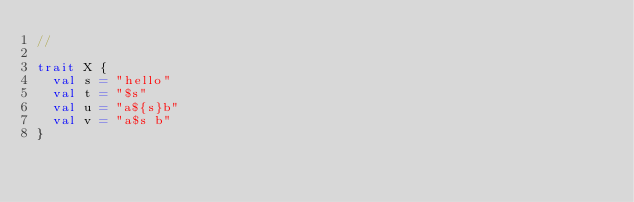<code> <loc_0><loc_0><loc_500><loc_500><_Scala_>//

trait X {
  val s = "hello"
  val t = "$s"
  val u = "a${s}b"
  val v = "a$s b"
}
</code> 